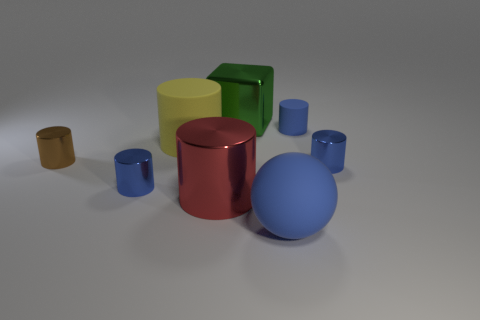What shape is the green thing that is the same material as the brown cylinder?
Make the answer very short. Cube. Is the number of big things greater than the number of big blue objects?
Ensure brevity in your answer.  Yes. There is a big red object; does it have the same shape as the big matte thing that is behind the tiny brown shiny cylinder?
Your answer should be very brief. Yes. What is the material of the tiny brown cylinder?
Give a very brief answer. Metal. The big cylinder behind the shiny cylinder to the right of the large metallic thing to the left of the block is what color?
Provide a short and direct response. Yellow. There is a big yellow object that is the same shape as the small brown object; what is it made of?
Keep it short and to the point. Rubber. How many yellow rubber objects have the same size as the red cylinder?
Your response must be concise. 1. How many brown metal cubes are there?
Make the answer very short. 0. Is the material of the cube the same as the object that is in front of the red metallic object?
Make the answer very short. No. How many cyan objects are things or tiny shiny objects?
Make the answer very short. 0. 